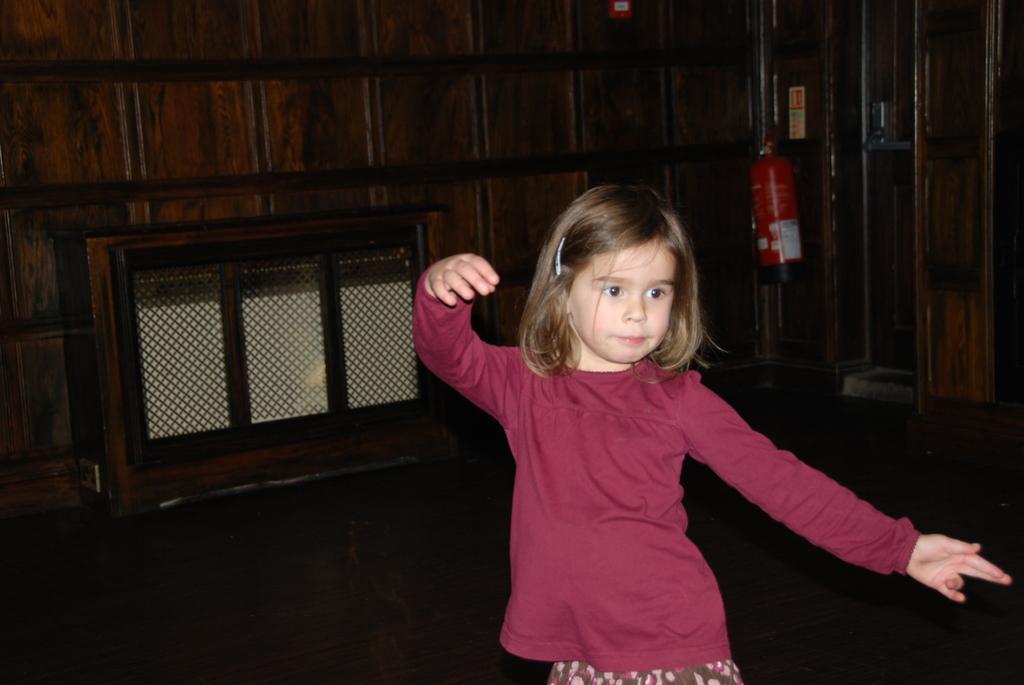Can you describe this image briefly? In this picture we can see a girl and in the background we can see a wooden wall,fire extinguisher. 